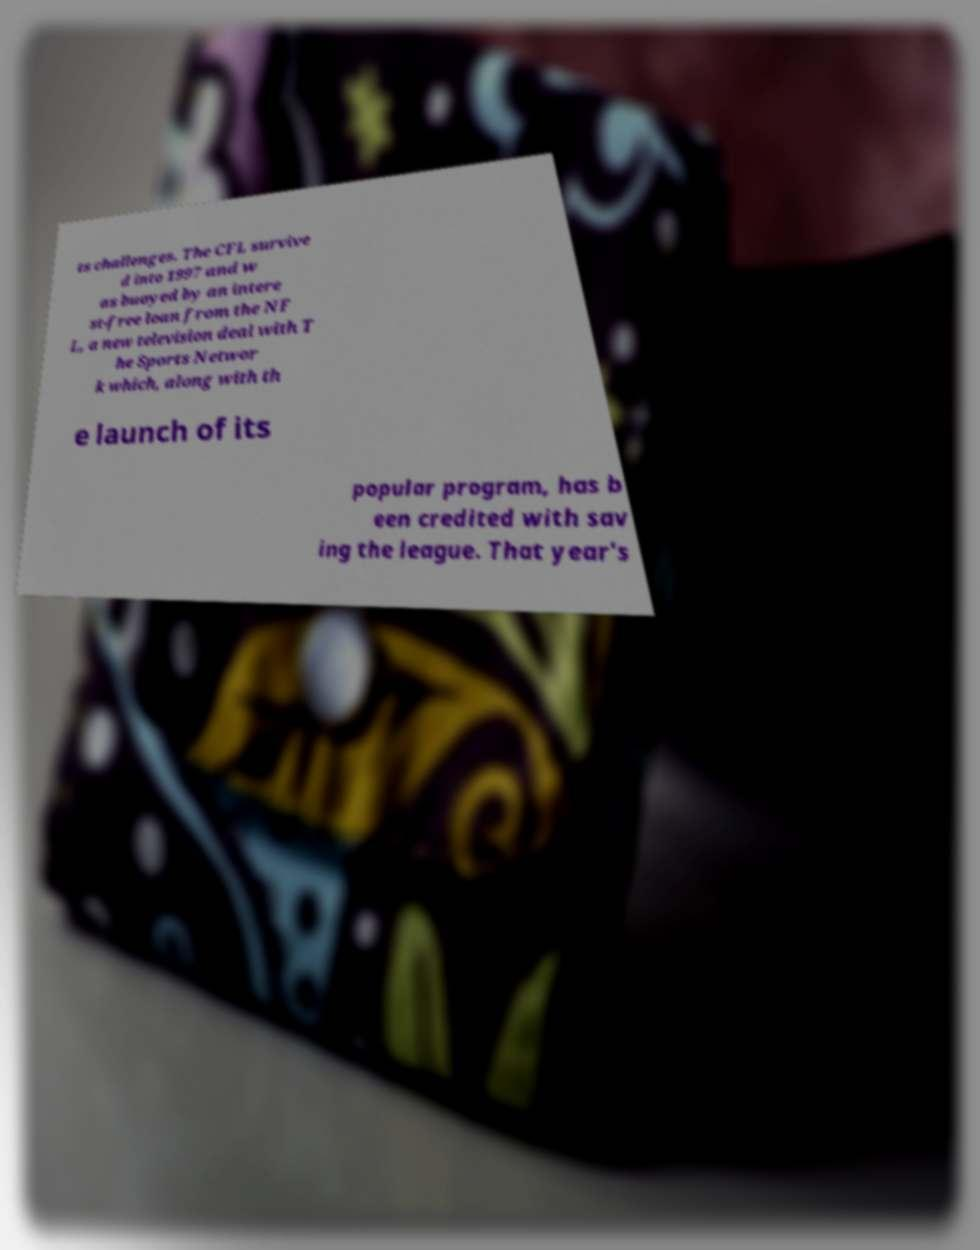What messages or text are displayed in this image? I need them in a readable, typed format. ts challenges. The CFL survive d into 1997 and w as buoyed by an intere st-free loan from the NF L, a new television deal with T he Sports Networ k which, along with th e launch of its popular program, has b een credited with sav ing the league. That year's 